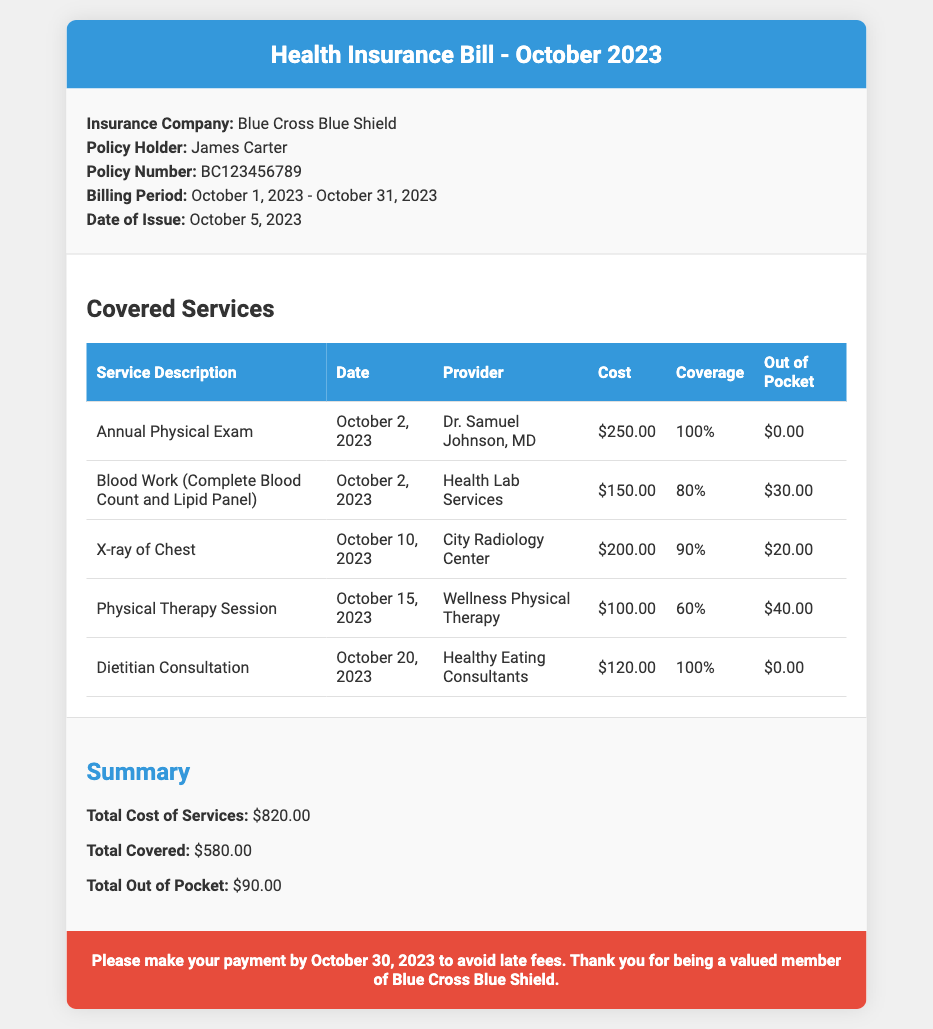what is the insurance company? The document states that the insurance company providing the coverage is Blue Cross Blue Shield.
Answer: Blue Cross Blue Shield who is the policy holder? The policy holder’s name is mentioned in the document as James Carter.
Answer: James Carter what is the date of issue? The date of issue for the health insurance bill is provided as October 5, 2023.
Answer: October 5, 2023 how much is the total cost of services? The total cost of services is clearly listed as $820.00 in the summary section of the document.
Answer: $820.00 what is the out-of-pocket expense for the Physical Therapy Session? The out-of-pocket expense for the Physical Therapy Session is mentioned as $40.00.
Answer: $40.00 which service had the highest coverage percentage? The service with the highest coverage percentage is the Annual Physical Exam, which has 100% coverage.
Answer: Annual Physical Exam what is the total covered amount? The total covered amount for the services provided is specified as $580.00 in the summary section.
Answer: $580.00 when is the payment due? The document notes that payment should be made by October 30, 2023, to avoid late fees.
Answer: October 30, 2023 what is the provider for the blood work? The provider listed for the blood work is Health Lab Services as per the covered services table.
Answer: Health Lab Services 